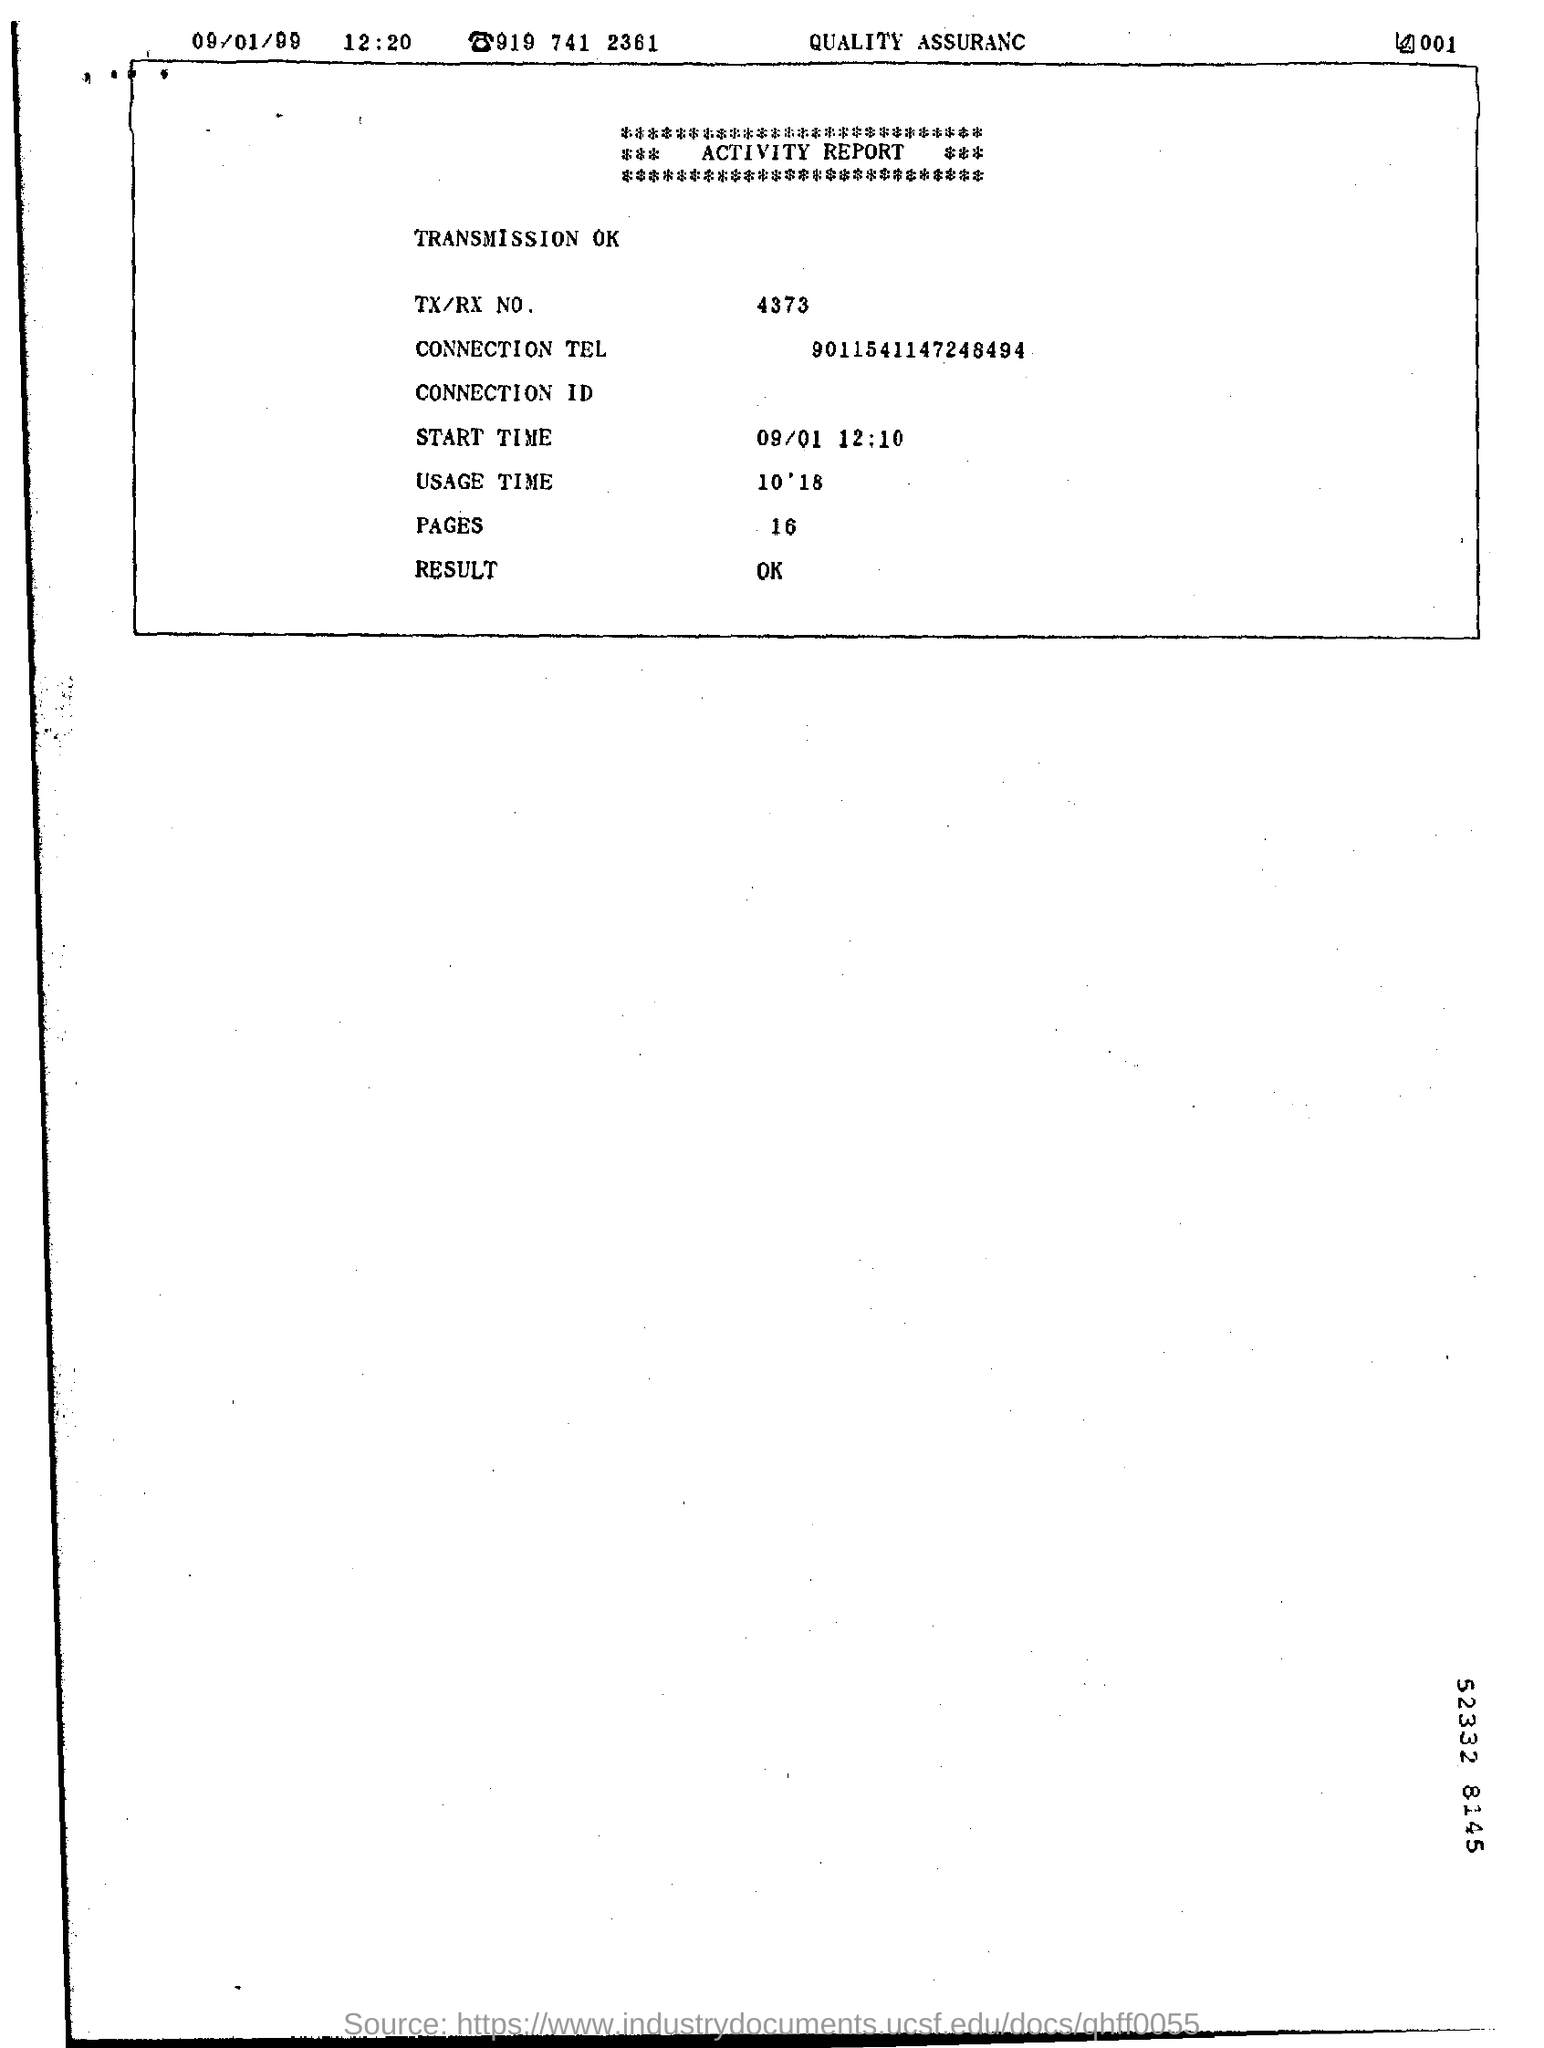What is the Connection Tel?
Offer a very short reply. 9011541147248494. What is the TX/RX No.?
Your answer should be very brief. 4373. What is the start time?
Ensure brevity in your answer.  12:10. What is the Usage Time?
Provide a succinct answer. 10'18. 